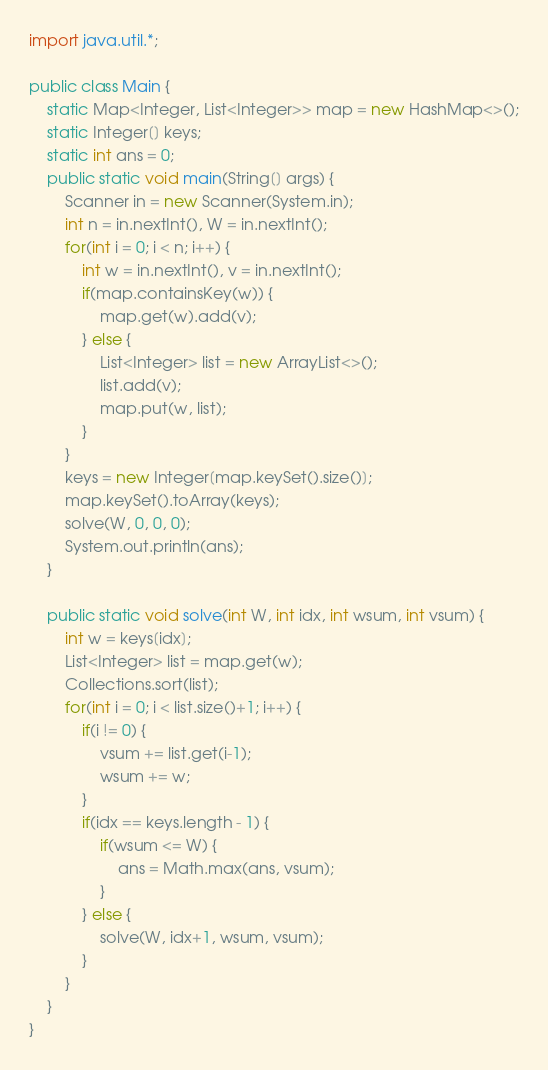Convert code to text. <code><loc_0><loc_0><loc_500><loc_500><_Java_>import java.util.*;

public class Main {
    static Map<Integer, List<Integer>> map = new HashMap<>();
    static Integer[] keys;
    static int ans = 0;
    public static void main(String[] args) {
        Scanner in = new Scanner(System.in);
        int n = in.nextInt(), W = in.nextInt();
        for(int i = 0; i < n; i++) {
            int w = in.nextInt(), v = in.nextInt();
            if(map.containsKey(w)) {
                map.get(w).add(v);
            } else {
                List<Integer> list = new ArrayList<>();
                list.add(v);
                map.put(w, list);
            }
        }
        keys = new Integer[map.keySet().size()];
        map.keySet().toArray(keys);
        solve(W, 0, 0, 0);
        System.out.println(ans);
    }

    public static void solve(int W, int idx, int wsum, int vsum) {
        int w = keys[idx];
        List<Integer> list = map.get(w);
        Collections.sort(list);
        for(int i = 0; i < list.size()+1; i++) {
            if(i != 0) {
                vsum += list.get(i-1);
                wsum += w;
            }
            if(idx == keys.length - 1) {
                if(wsum <= W) {
                    ans = Math.max(ans, vsum);
                }
            } else {
                solve(W, idx+1, wsum, vsum);
            }
        }
    }
}</code> 